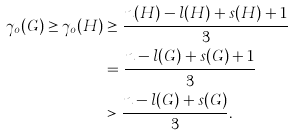<formula> <loc_0><loc_0><loc_500><loc_500>\gamma _ { o } ( G ) \geq \gamma _ { o } ( H ) & \geq \frac { n ( H ) - l ( H ) + s ( H ) + 1 } { 3 } \\ & = \frac { n - l ( G ) + s ( G ) + 1 } { 3 } \\ & > \frac { n - l ( G ) + s ( G ) } { 3 } .</formula> 